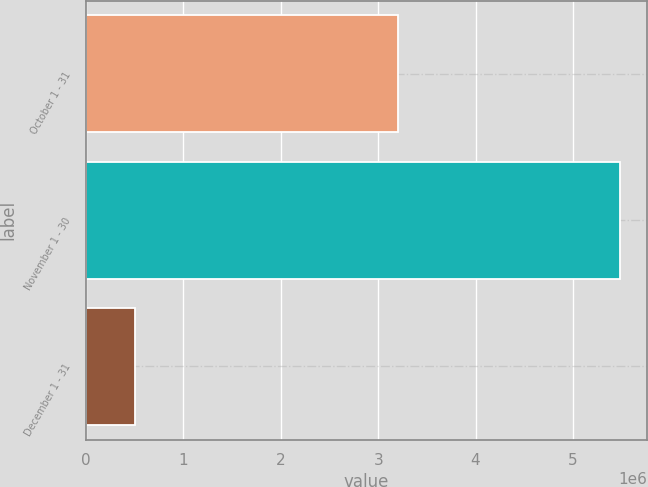Convert chart to OTSL. <chart><loc_0><loc_0><loc_500><loc_500><bar_chart><fcel>October 1 - 31<fcel>November 1 - 30<fcel>December 1 - 31<nl><fcel>3.2077e+06<fcel>5.4877e+06<fcel>499204<nl></chart> 